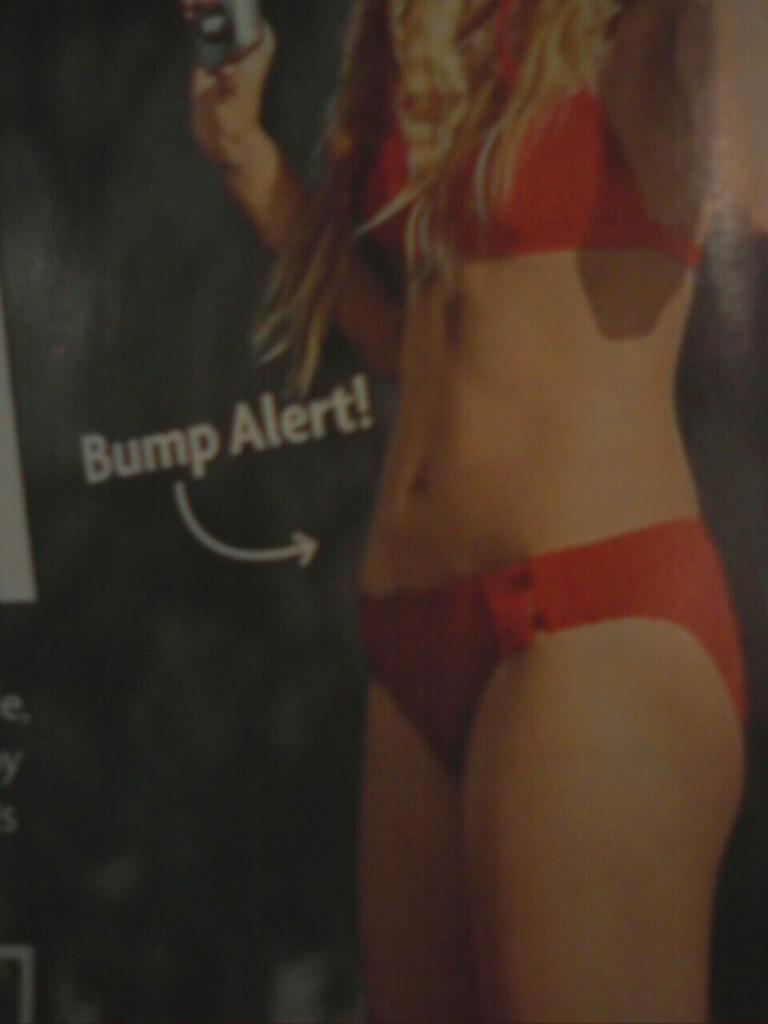Who is present in the image? There is a woman in the image. What is the woman wearing? The woman is wearing a red bikini. Can you describe any text or writing in the image? Yes, there is something written in white color in the image. What type of coal can be seen in the image? There is no coal present in the image. Can you describe the patch of land in the image? There is no mention of a patch of land in the provided facts, so it cannot be described. 